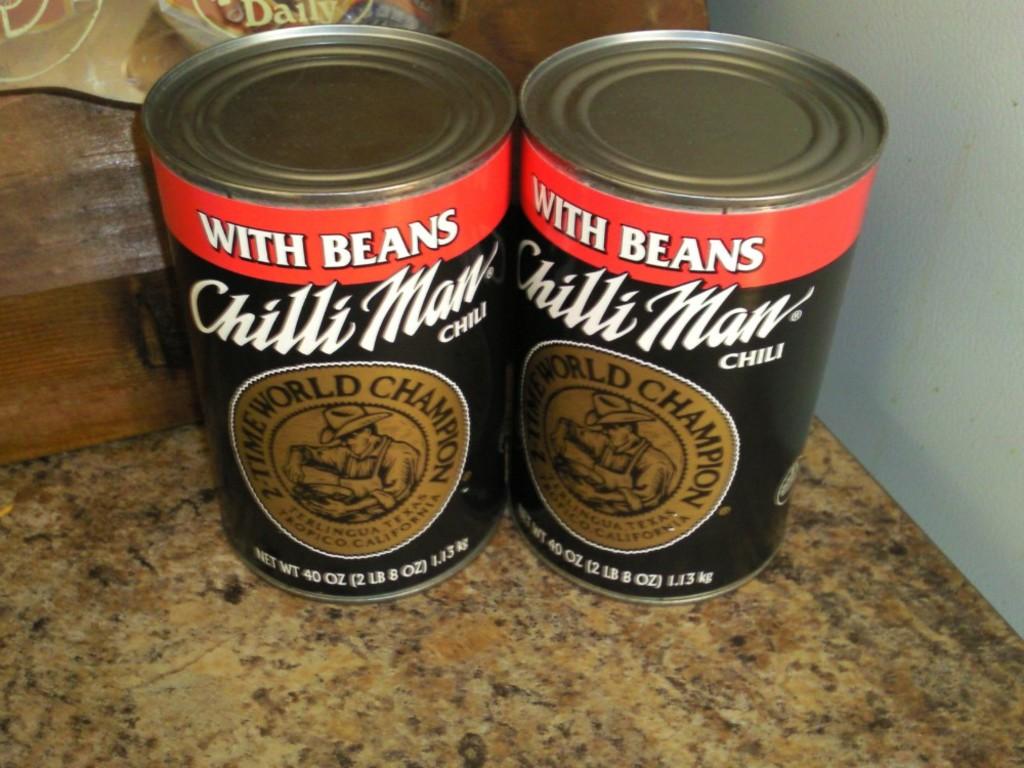What brand is the chili/?
Provide a short and direct response. Chilli man. 